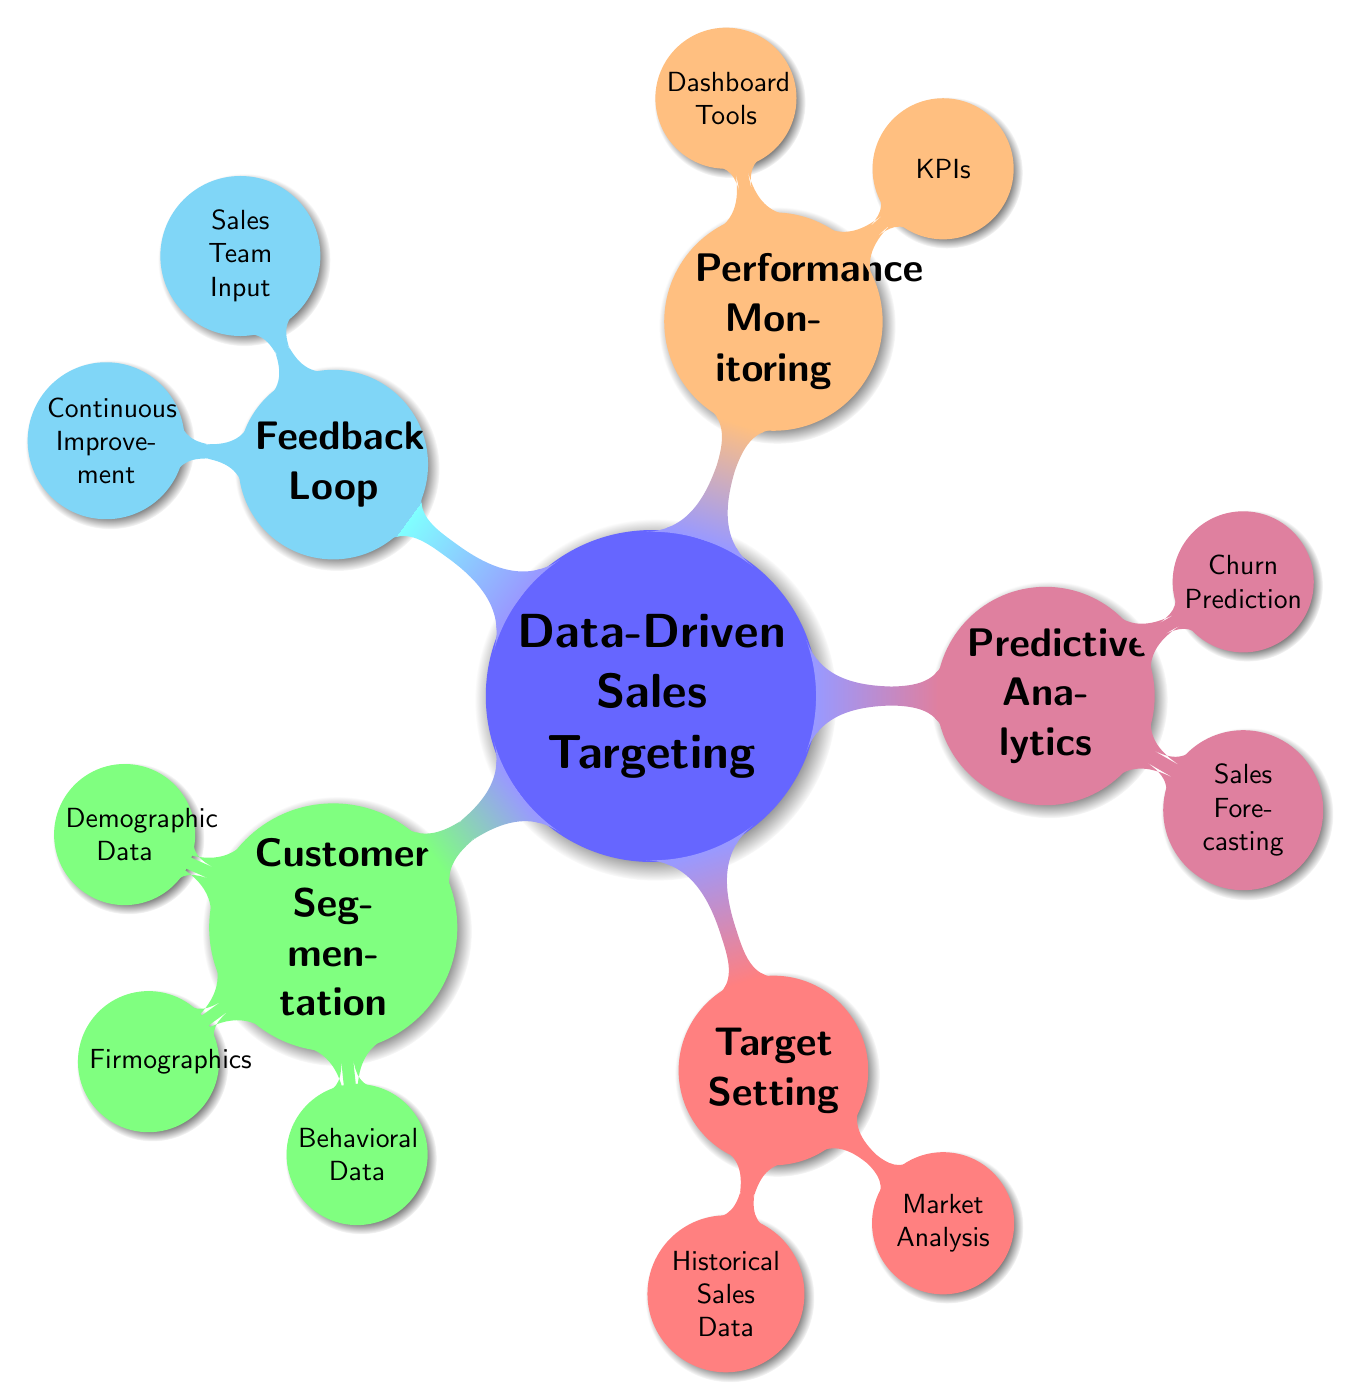What is the main topic of the mind map? The central node of the mind map is labeled "Data-Driven Sales Targeting," which represents the overall theme of the diagram.
Answer: Data-Driven Sales Targeting How many main branches are there in the mind map? The mind map has five main branches stemming from the root concept, which are Customer Segmentation, Target Setting, Predictive Analytics, Performance Monitoring, and Feedback Loop.
Answer: Five What data type is included under Customer Segmentation? Under the Customer Segmentation branch, there are three data types listed: Demographic Data, Firmographics, and Behavioral Data, which are clearly identified in the respective child nodes.
Answer: Demographic Data, Firmographics, Behavioral Data Which section gives insights into future sales trends? The Sales Forecasting node under the Predictive Analytics branch focuses on understanding future sales trends and strategies through time series analysis and machine learning models.
Answer: Sales Forecasting What is one of the KPIs mentioned for Performance Monitoring? The Performance Monitoring section includes KPIs such as Conversion Rates, Customer Acquisition Cost, and Lifetime Value; any one of these can be identified as representative KPIs.
Answer: Conversion Rates How does the diagram connect Customer Segmentation to Performance Monitoring? Although there is no direct link shown between Customer Segmentation and Performance Monitoring, understanding the customer segments can indirectly assist in setting performance metrics, as different segments may impact the KPIs differently.
Answer: Indirectly (through understanding customer segments) What can be improved through the Feedback Loop? The Feedback Loop section highlights Continuous Improvement mechanisms, which focus on enhancing sales processes and strategies based on feedback and testing.
Answer: Continuous Improvement Which tool is listed under Dashboard Tools? The Dashboard Tools node mentions specific visualization tools such as Tableau, Power BI, and Google Data Studio, any of which can enhance data analysis and presentation.
Answer: Tableau What is the relationship between Historical Sales Data and Market Analysis? Both Historical Sales Data and Market Analysis are components of the Target Setting branch, which collectively aids in establishing informed sales targets based on past and competitive performance.
Answer: They are both part of Target Setting 